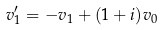Convert formula to latex. <formula><loc_0><loc_0><loc_500><loc_500>v _ { 1 } ^ { \prime } = - v _ { 1 } + ( 1 + i ) v _ { 0 }</formula> 